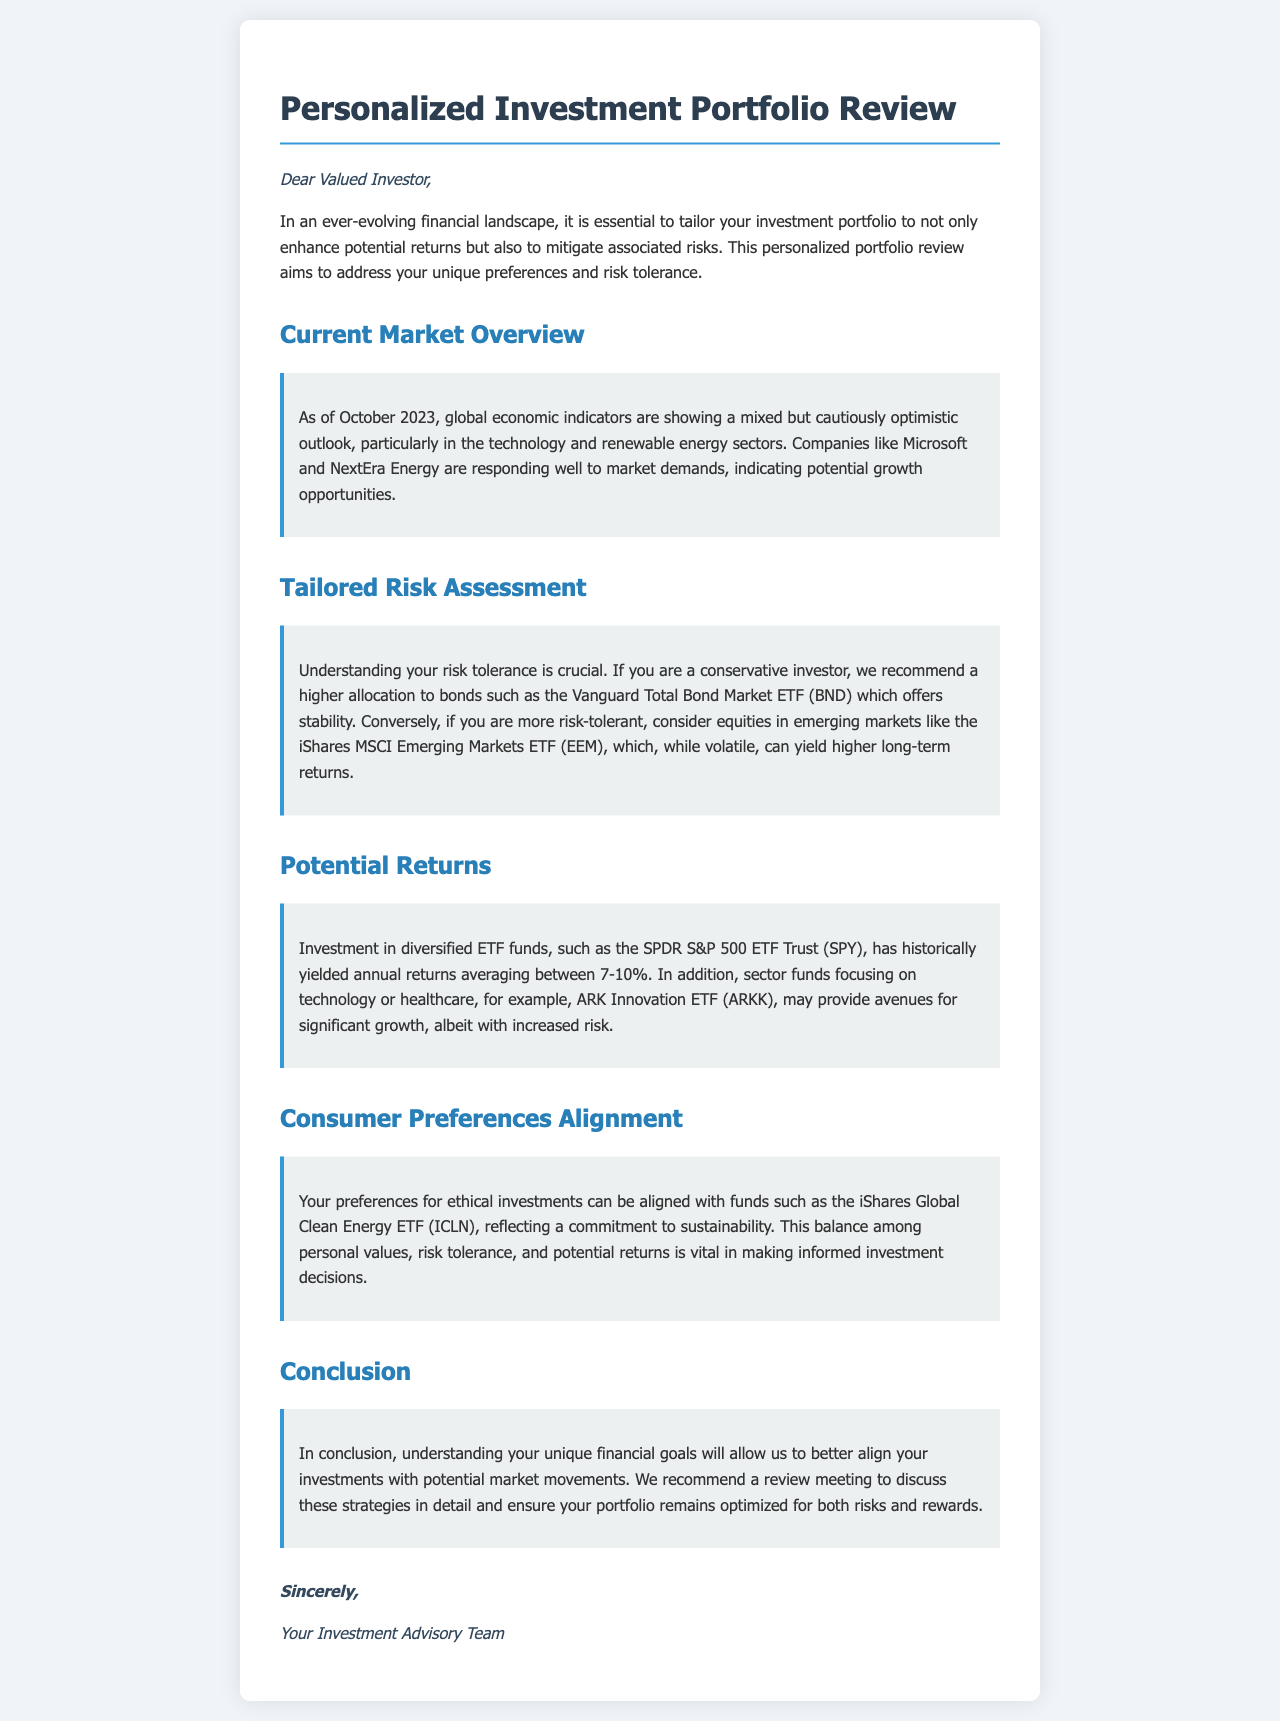What is the title of the document? The title is the main heading of the document, which introduces the subject of the letter.
Answer: Personalized Investment Portfolio Review What sectors show potential growth opportunities? The sectors that indicate potential growth opportunities are specified in the market overview section.
Answer: Technology and renewable energy Which ETF is recommended for conservative investors? The recommendation for conservative investors is found in the tailored risk assessment section of the document.
Answer: Vanguard Total Bond Market ETF (BND) What is the historical average return range for SPDR S&P 500 ETF Trust (SPY)? This information is stated in the potential returns section, providing insights on expected performance.
Answer: 7-10% Which ETF aligns with ethical investment preferences? This query relates to how the document addresses consumer preferences for ethical investment options.
Answer: iShares Global Clean Energy ETF (ICLN) What should be discussed in a review meeting? This question pertains to the concluding remarks in the document outlining the purpose of the meeting.
Answer: Strategies in detail What is the purpose of the personalized portfolio review? The purpose is explained in the introductory paragraph, focusing on investment enhancement and risk mitigation.
Answer: Tailor your investment portfolio What date is mentioned in the current market overview? This date serves as the reference point for the information presented in the section.
Answer: October 2023 